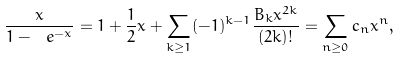<formula> <loc_0><loc_0><loc_500><loc_500>\frac { x } { 1 - \ e ^ { - x } } = 1 + \frac { 1 } { 2 } x + \sum _ { k \geq 1 } ( - 1 ) ^ { k - 1 } \frac { B _ { k } x ^ { 2 k } } { ( 2 k ) ! } = \sum _ { n \geq 0 } c _ { n } x ^ { n } ,</formula> 